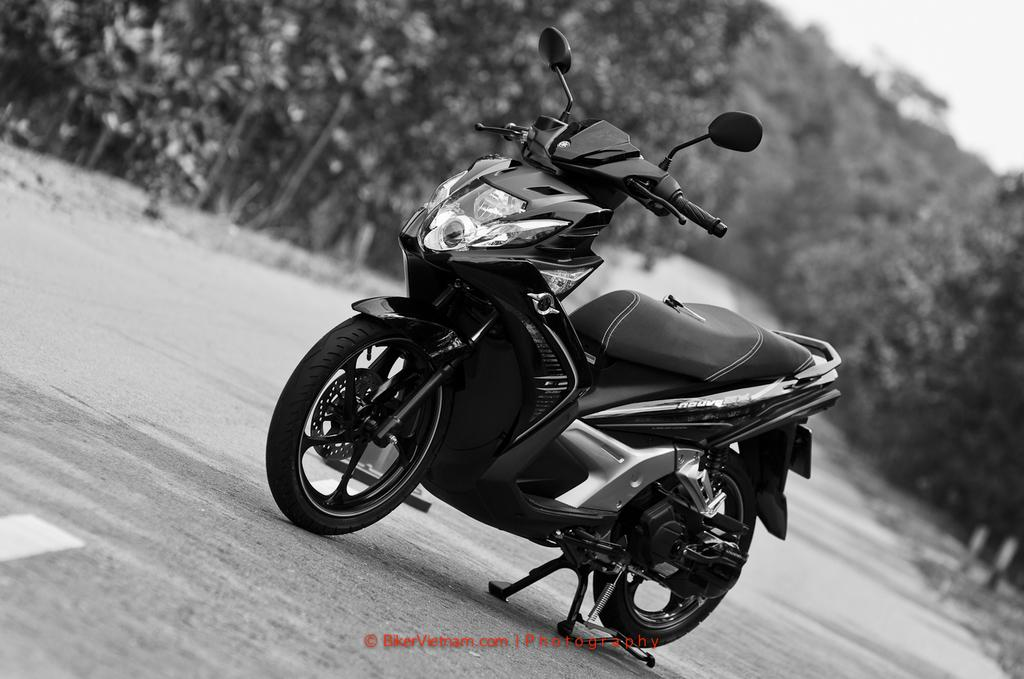What is the main subject of the image? The main subject of the image is a motorcycle. Where is the motorcycle located? The motorcycle is on the road. What can be seen in the background of the image? There are trees in the background of the image. What is present at the bottom of the image? There is text visible at the bottom of the image. What type of linen is draped over the motorcycle in the image? There is no linen draped over the motorcycle in the image. What trick is the motorcycle performing in the image? The motorcycle is not performing any tricks in the image; it is simply on the road. 